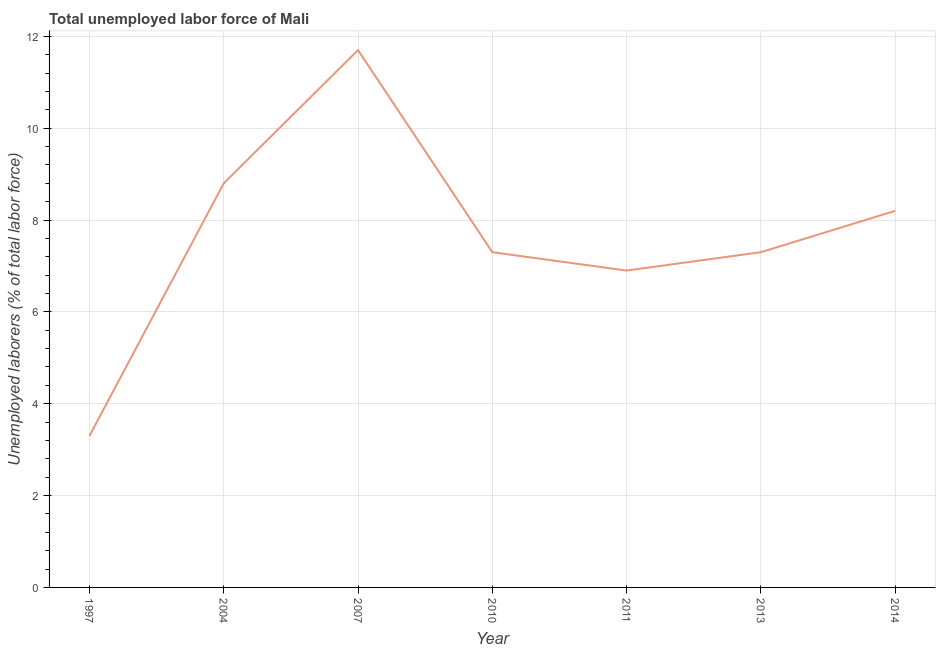What is the total unemployed labour force in 2007?
Your answer should be very brief. 11.7. Across all years, what is the maximum total unemployed labour force?
Keep it short and to the point. 11.7. Across all years, what is the minimum total unemployed labour force?
Offer a very short reply. 3.3. What is the sum of the total unemployed labour force?
Make the answer very short. 53.5. What is the difference between the total unemployed labour force in 2007 and 2014?
Offer a terse response. 3.5. What is the average total unemployed labour force per year?
Give a very brief answer. 7.64. What is the median total unemployed labour force?
Provide a succinct answer. 7.3. Do a majority of the years between 2010 and 1997 (inclusive) have total unemployed labour force greater than 5.6 %?
Your response must be concise. Yes. What is the ratio of the total unemployed labour force in 2004 to that in 2011?
Your answer should be compact. 1.28. Is the difference between the total unemployed labour force in 2007 and 2011 greater than the difference between any two years?
Your answer should be very brief. No. What is the difference between the highest and the second highest total unemployed labour force?
Ensure brevity in your answer.  2.9. Is the sum of the total unemployed labour force in 2007 and 2014 greater than the maximum total unemployed labour force across all years?
Give a very brief answer. Yes. What is the difference between the highest and the lowest total unemployed labour force?
Give a very brief answer. 8.4. In how many years, is the total unemployed labour force greater than the average total unemployed labour force taken over all years?
Make the answer very short. 3. Does the total unemployed labour force monotonically increase over the years?
Give a very brief answer. No. How many lines are there?
Keep it short and to the point. 1. How many years are there in the graph?
Offer a terse response. 7. What is the difference between two consecutive major ticks on the Y-axis?
Offer a very short reply. 2. Are the values on the major ticks of Y-axis written in scientific E-notation?
Offer a very short reply. No. Does the graph contain grids?
Provide a short and direct response. Yes. What is the title of the graph?
Your response must be concise. Total unemployed labor force of Mali. What is the label or title of the X-axis?
Your answer should be very brief. Year. What is the label or title of the Y-axis?
Provide a succinct answer. Unemployed laborers (% of total labor force). What is the Unemployed laborers (% of total labor force) of 1997?
Provide a short and direct response. 3.3. What is the Unemployed laborers (% of total labor force) of 2004?
Provide a short and direct response. 8.8. What is the Unemployed laborers (% of total labor force) of 2007?
Give a very brief answer. 11.7. What is the Unemployed laborers (% of total labor force) of 2010?
Offer a very short reply. 7.3. What is the Unemployed laborers (% of total labor force) in 2011?
Your answer should be compact. 6.9. What is the Unemployed laborers (% of total labor force) of 2013?
Ensure brevity in your answer.  7.3. What is the Unemployed laborers (% of total labor force) in 2014?
Your answer should be compact. 8.2. What is the difference between the Unemployed laborers (% of total labor force) in 1997 and 2004?
Keep it short and to the point. -5.5. What is the difference between the Unemployed laborers (% of total labor force) in 1997 and 2013?
Offer a very short reply. -4. What is the difference between the Unemployed laborers (% of total labor force) in 1997 and 2014?
Make the answer very short. -4.9. What is the difference between the Unemployed laborers (% of total labor force) in 2004 and 2007?
Your answer should be compact. -2.9. What is the difference between the Unemployed laborers (% of total labor force) in 2004 and 2010?
Provide a short and direct response. 1.5. What is the difference between the Unemployed laborers (% of total labor force) in 2004 and 2011?
Offer a very short reply. 1.9. What is the difference between the Unemployed laborers (% of total labor force) in 2004 and 2014?
Your response must be concise. 0.6. What is the difference between the Unemployed laborers (% of total labor force) in 2010 and 2013?
Make the answer very short. 0. What is the difference between the Unemployed laborers (% of total labor force) in 2011 and 2014?
Your response must be concise. -1.3. What is the difference between the Unemployed laborers (% of total labor force) in 2013 and 2014?
Make the answer very short. -0.9. What is the ratio of the Unemployed laborers (% of total labor force) in 1997 to that in 2007?
Your answer should be compact. 0.28. What is the ratio of the Unemployed laborers (% of total labor force) in 1997 to that in 2010?
Offer a terse response. 0.45. What is the ratio of the Unemployed laborers (% of total labor force) in 1997 to that in 2011?
Keep it short and to the point. 0.48. What is the ratio of the Unemployed laborers (% of total labor force) in 1997 to that in 2013?
Your answer should be compact. 0.45. What is the ratio of the Unemployed laborers (% of total labor force) in 1997 to that in 2014?
Your answer should be compact. 0.4. What is the ratio of the Unemployed laborers (% of total labor force) in 2004 to that in 2007?
Make the answer very short. 0.75. What is the ratio of the Unemployed laborers (% of total labor force) in 2004 to that in 2010?
Offer a terse response. 1.21. What is the ratio of the Unemployed laborers (% of total labor force) in 2004 to that in 2011?
Provide a succinct answer. 1.27. What is the ratio of the Unemployed laborers (% of total labor force) in 2004 to that in 2013?
Offer a very short reply. 1.21. What is the ratio of the Unemployed laborers (% of total labor force) in 2004 to that in 2014?
Keep it short and to the point. 1.07. What is the ratio of the Unemployed laborers (% of total labor force) in 2007 to that in 2010?
Keep it short and to the point. 1.6. What is the ratio of the Unemployed laborers (% of total labor force) in 2007 to that in 2011?
Keep it short and to the point. 1.7. What is the ratio of the Unemployed laborers (% of total labor force) in 2007 to that in 2013?
Your answer should be compact. 1.6. What is the ratio of the Unemployed laborers (% of total labor force) in 2007 to that in 2014?
Offer a terse response. 1.43. What is the ratio of the Unemployed laborers (% of total labor force) in 2010 to that in 2011?
Your answer should be compact. 1.06. What is the ratio of the Unemployed laborers (% of total labor force) in 2010 to that in 2013?
Make the answer very short. 1. What is the ratio of the Unemployed laborers (% of total labor force) in 2010 to that in 2014?
Your response must be concise. 0.89. What is the ratio of the Unemployed laborers (% of total labor force) in 2011 to that in 2013?
Your answer should be compact. 0.94. What is the ratio of the Unemployed laborers (% of total labor force) in 2011 to that in 2014?
Provide a short and direct response. 0.84. What is the ratio of the Unemployed laborers (% of total labor force) in 2013 to that in 2014?
Your response must be concise. 0.89. 